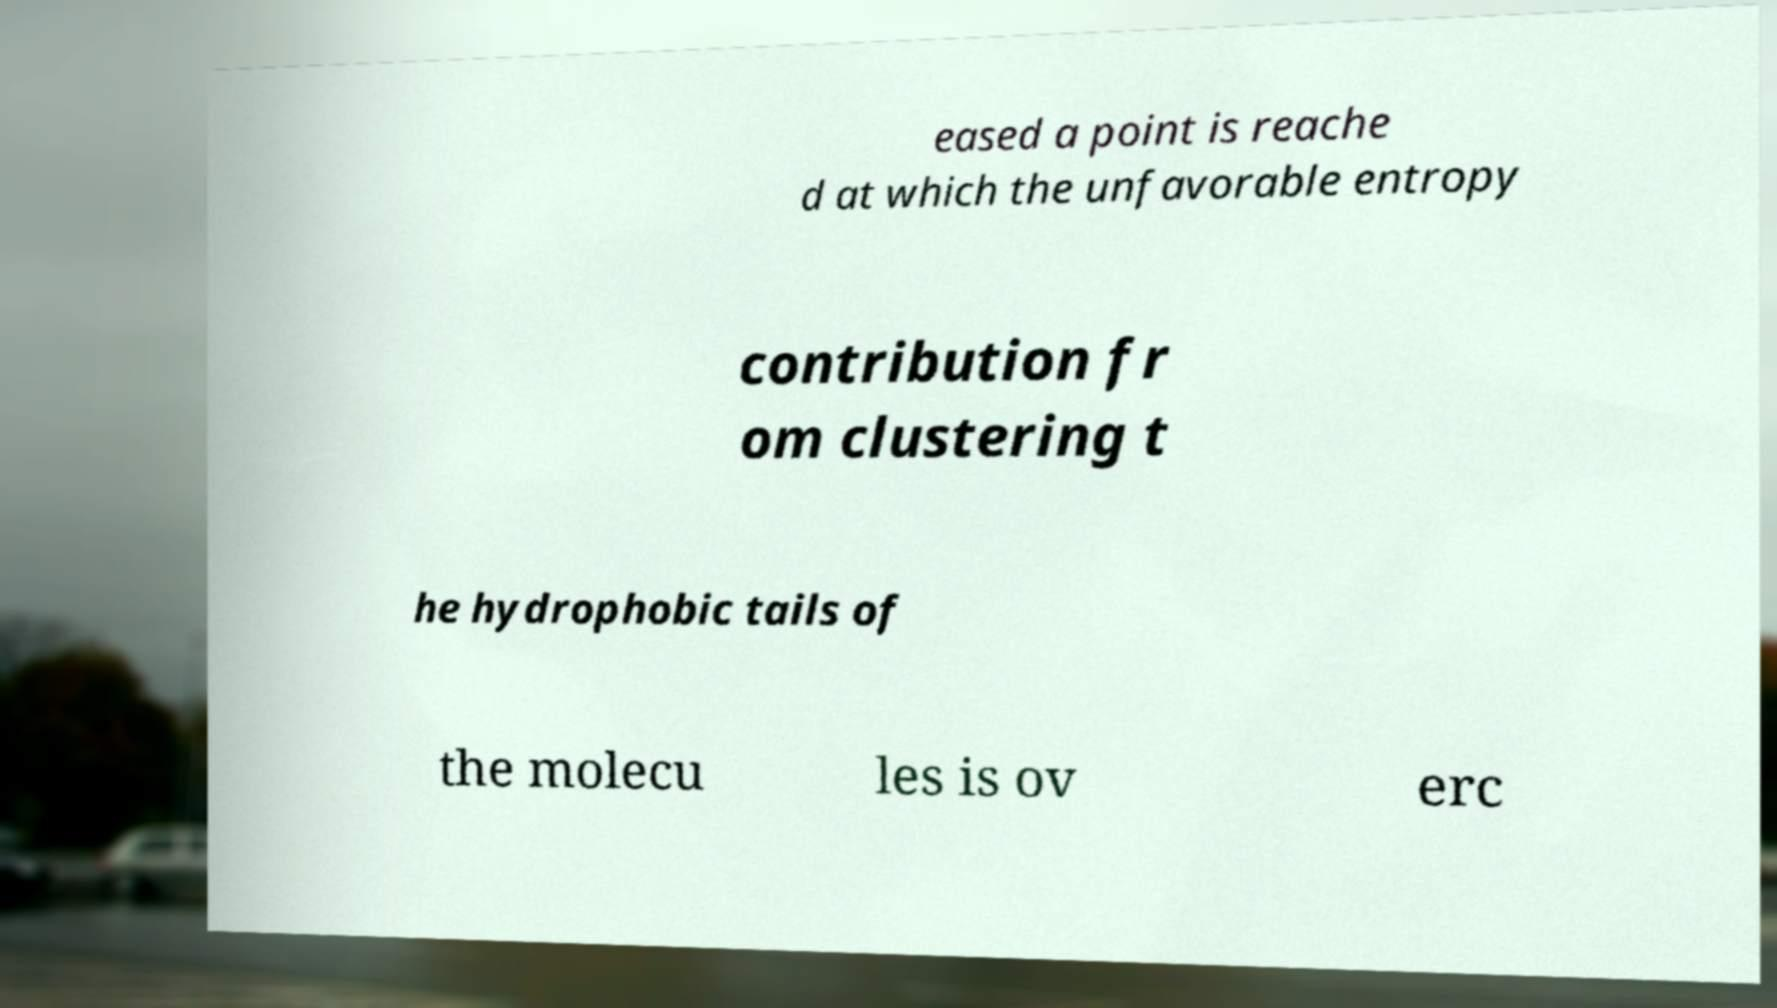Please read and relay the text visible in this image. What does it say? eased a point is reache d at which the unfavorable entropy contribution fr om clustering t he hydrophobic tails of the molecu les is ov erc 